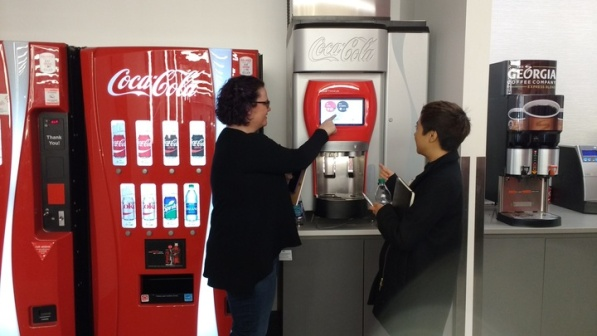How do the designs of these machines appeal to different age groups? The modern touchscreen vending machine might appeal more to younger, tech-friendly consumers who appreciate digital interfaces similar to those on smartphones and tablets. This machine could be attractive due to its interactive display and the ability to easily incorporate new technologies like contactless payments. In contrast, the older, button-operated machine has a straightforward design that might be more comforting and easier to use for older adults or those who prefer a more tactile and less tech-intensive experience. The clear, physical buttons reduce confusion, making it accessible to all age groups but particularly reassuring to those not accustomed to digital screens. 